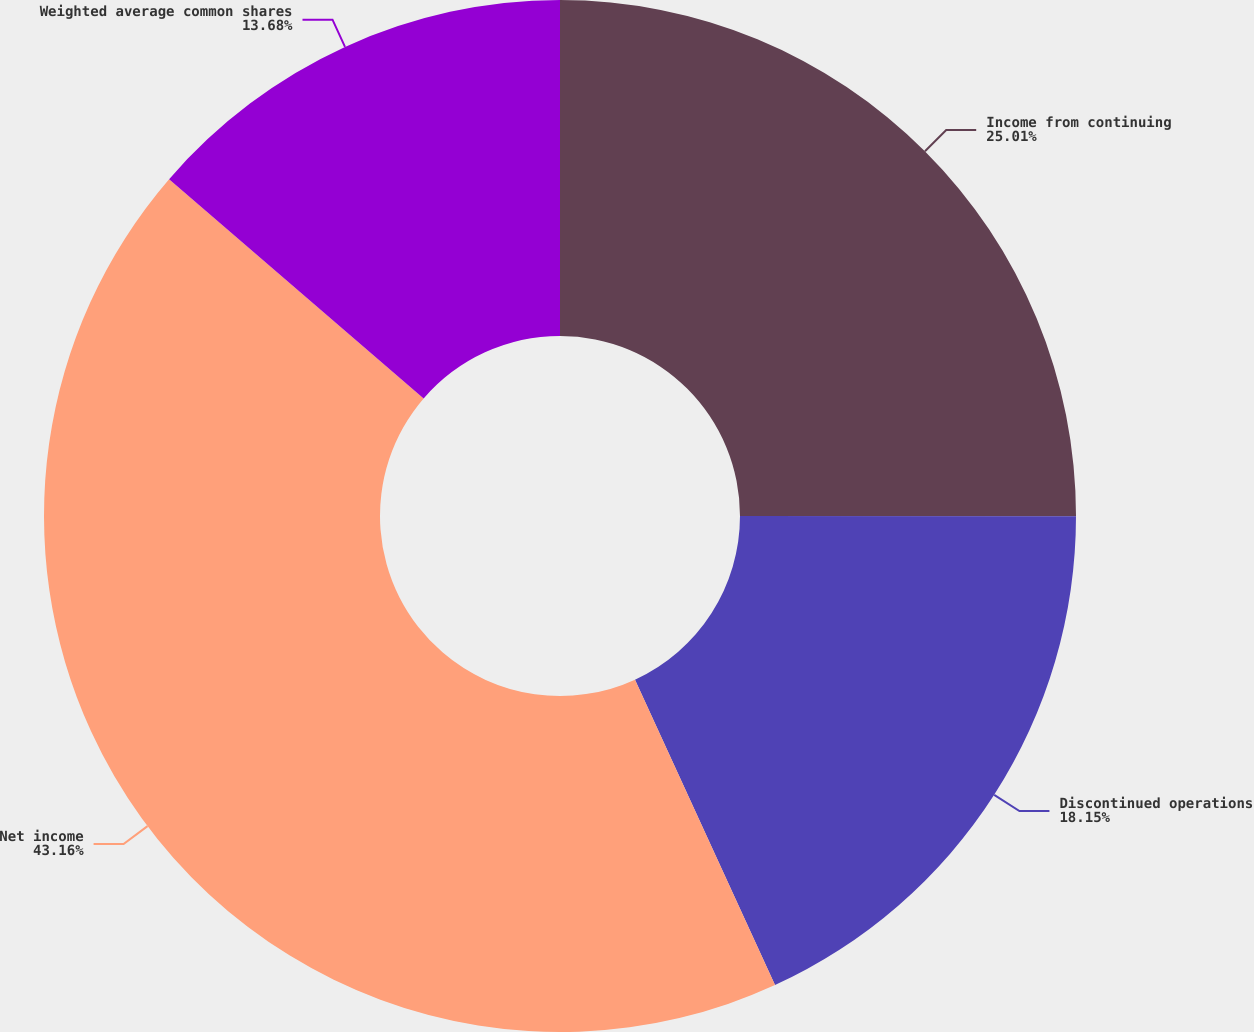<chart> <loc_0><loc_0><loc_500><loc_500><pie_chart><fcel>Income from continuing<fcel>Discontinued operations<fcel>Net income<fcel>Weighted average common shares<nl><fcel>25.01%<fcel>18.15%<fcel>43.16%<fcel>13.68%<nl></chart> 